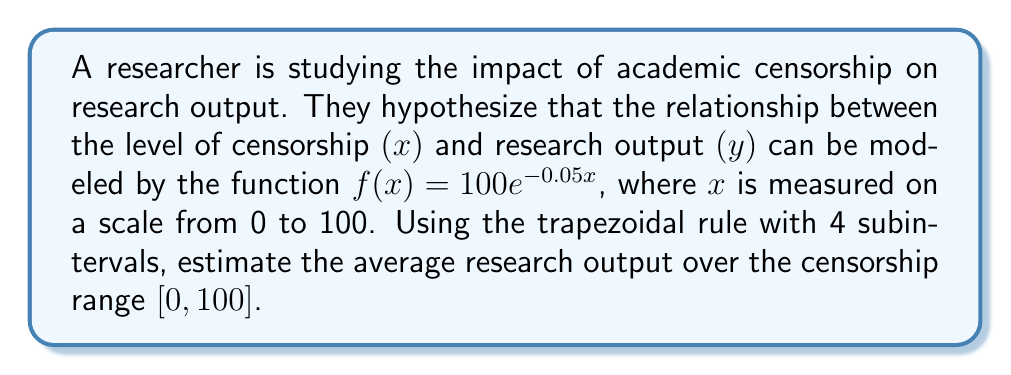Can you solve this math problem? 1) The trapezoidal rule for $n$ subintervals is given by:

   $$\int_a^b f(x)dx \approx \frac{b-a}{2n}[f(a) + 2f(x_1) + 2f(x_2) + ... + 2f(x_{n-1}) + f(b)]$$

2) Here, $a=0$, $b=100$, and $n=4$. The width of each subinterval is $h = \frac{b-a}{n} = \frac{100-0}{4} = 25$.

3) We need to evaluate $f(x)$ at $x = 0, 25, 50, 75,$ and $100$:

   $f(0) = 100e^{-0.05(0)} = 100$
   $f(25) = 100e^{-0.05(25)} \approx 28.65$
   $f(50) = 100e^{-0.05(50)} \approx 8.21$
   $f(75) = 100e^{-0.05(75)} \approx 2.35$
   $f(100) = 100e^{-0.05(100)} \approx 0.67$

4) Applying the trapezoidal rule:

   $$\int_0^{100} f(x)dx \approx \frac{100-0}{2(4)}[100 + 2(28.65) + 2(8.21) + 2(2.35) + 0.67]$$
   $$= 12.5[100 + 57.3 + 16.42 + 4.7 + 0.67]$$
   $$= 12.5(179.09) \approx 2238.625$$

5) To find the average, we divide by the interval width:

   Average $= \frac{2238.625}{100} \approx 22.39$

Thus, the estimated average research output over the censorship range $[0, 100]$ is approximately 22.39.
Answer: 22.39 